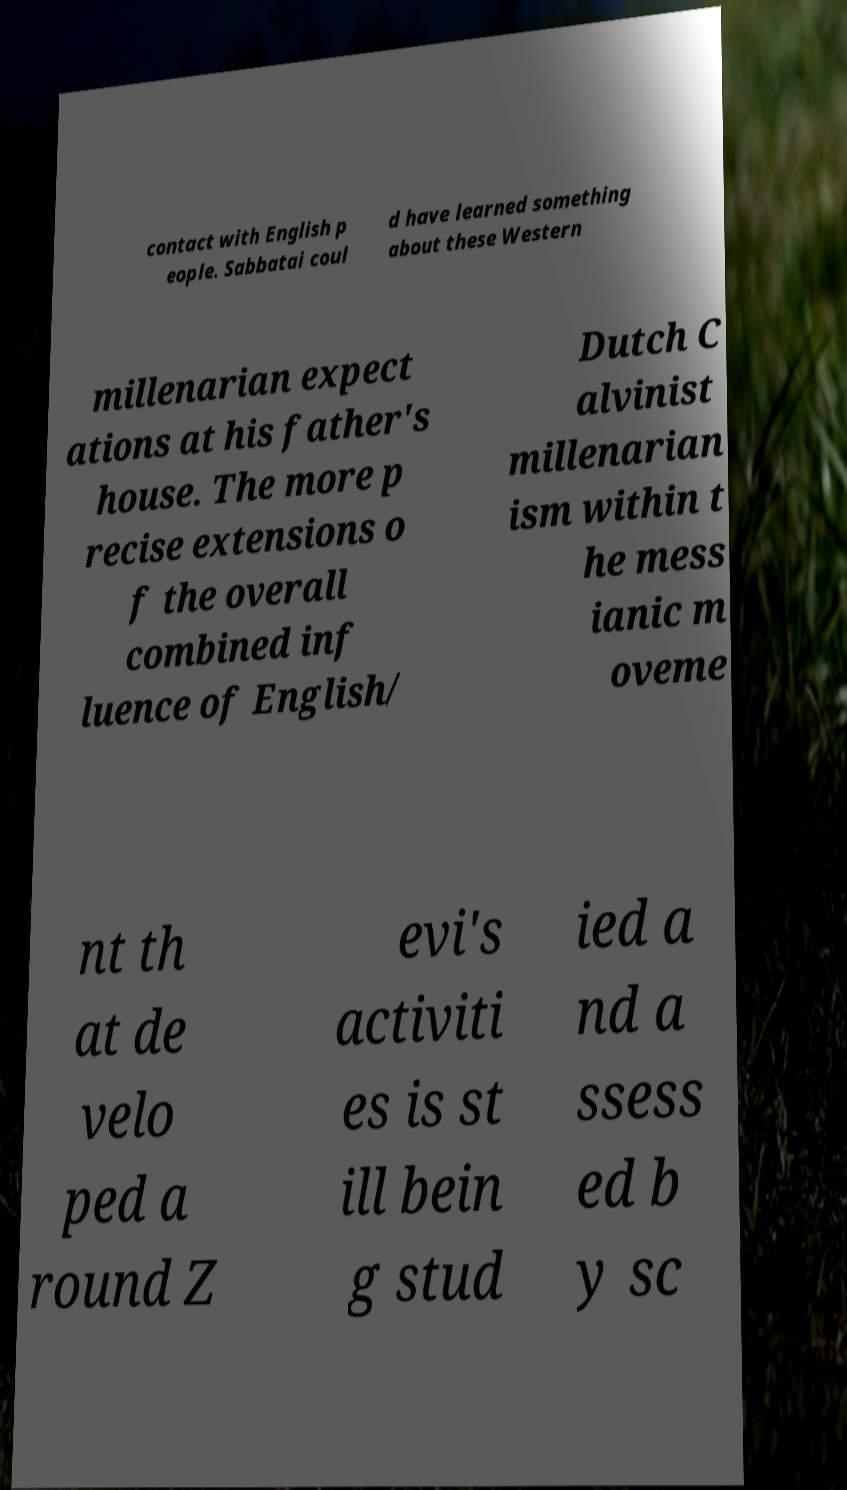Please read and relay the text visible in this image. What does it say? contact with English p eople. Sabbatai coul d have learned something about these Western millenarian expect ations at his father's house. The more p recise extensions o f the overall combined inf luence of English/ Dutch C alvinist millenarian ism within t he mess ianic m oveme nt th at de velo ped a round Z evi's activiti es is st ill bein g stud ied a nd a ssess ed b y sc 